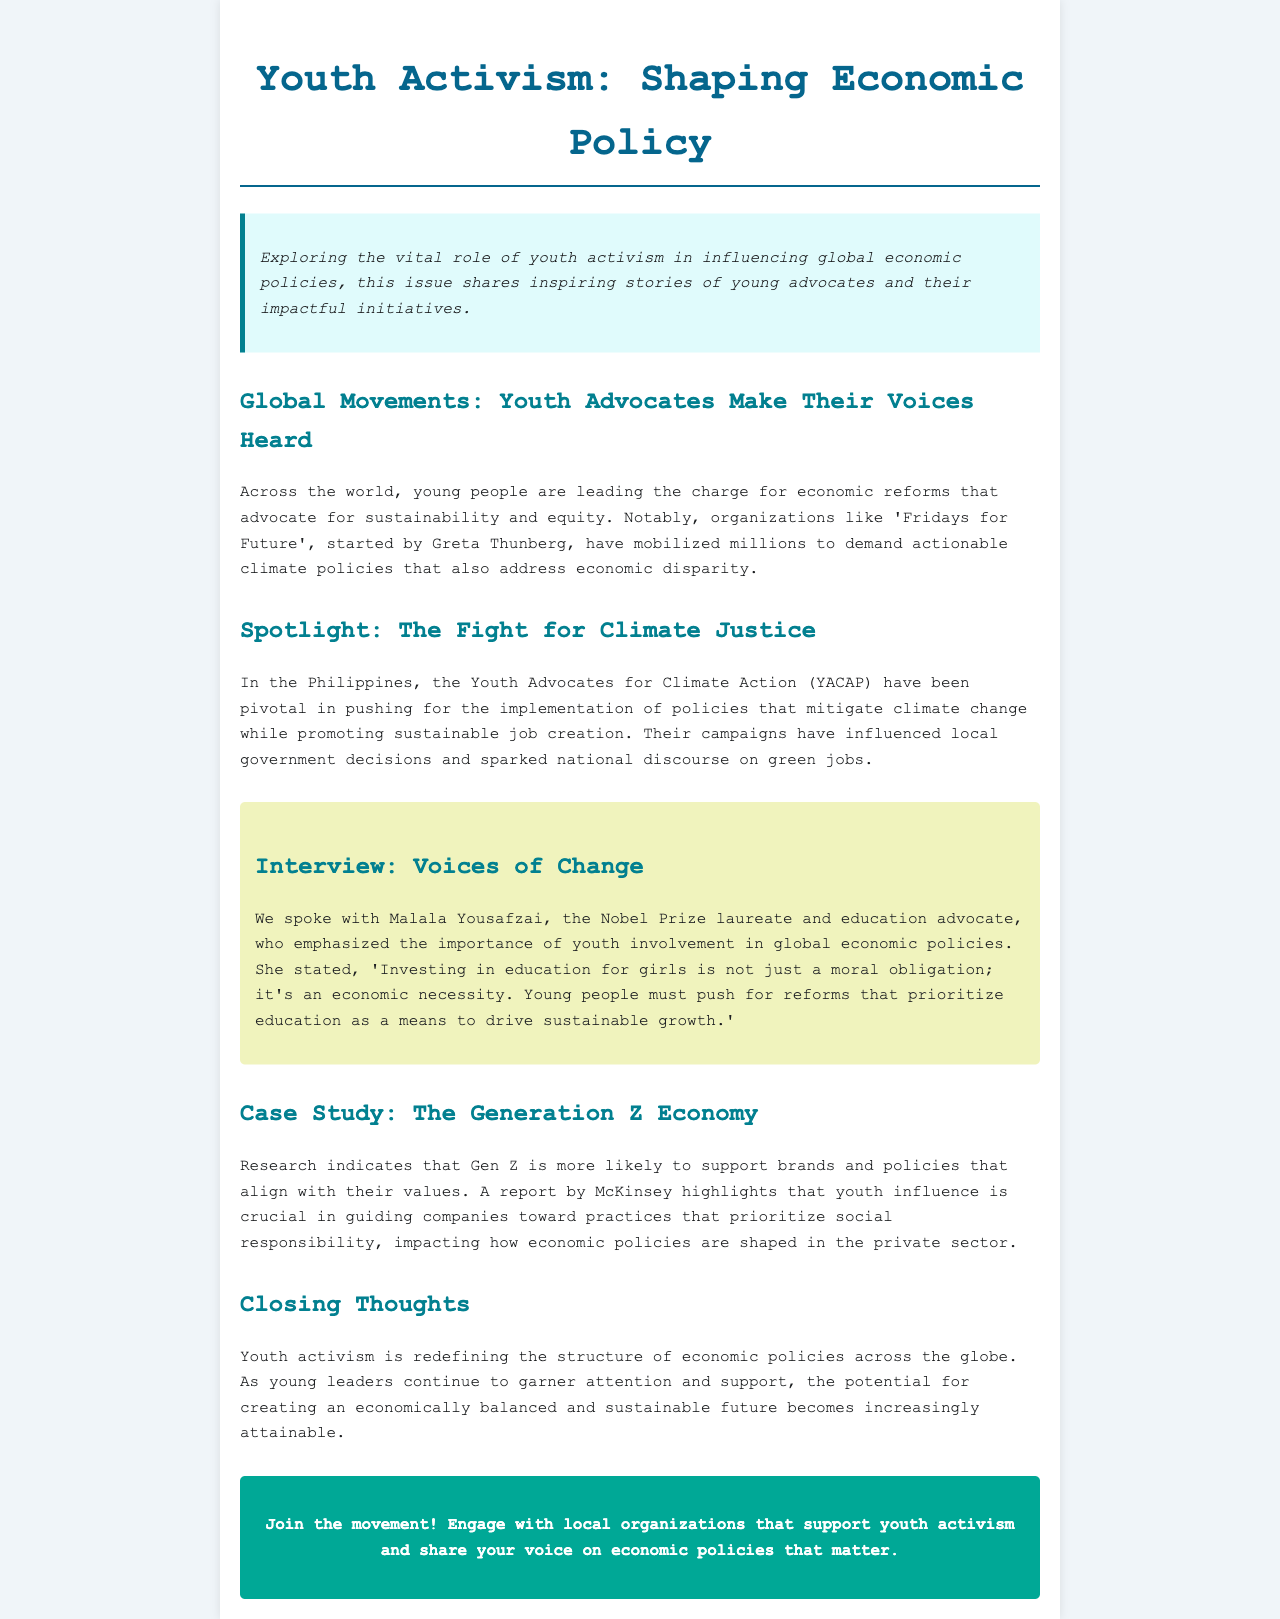What is the title of the newsletter? The title of the newsletter is stated at the top of the document.
Answer: Youth Activism: Shaping Economic Policy Who started 'Fridays for Future'? The document mentions the key figure associated with this organization.
Answer: Greta Thunberg What organization is mentioned in the Philippines? The document highlights a specific youth organization active in climate advocacy in the Philippines.
Answer: Youth Advocates for Climate Action (YACAP) What important quality does Malala Yousafzai emphasize for youth activism? The document discusses a critical aspect that Malala believes should be prioritized in youth activism.
Answer: Education Which generation is highlighted as influencing brands and policies? The document identifies the specific generation that is more likely to support socially responsible practices.
Answer: Gen Z What is the main topic of the "Closing Thoughts" section? The document describes the overarching theme addressed in the closing section.
Answer: Economic policies How does the document encourage community involvement? The document provides a call to action at the end, focusing on local engagement.
Answer: Join the movement! 